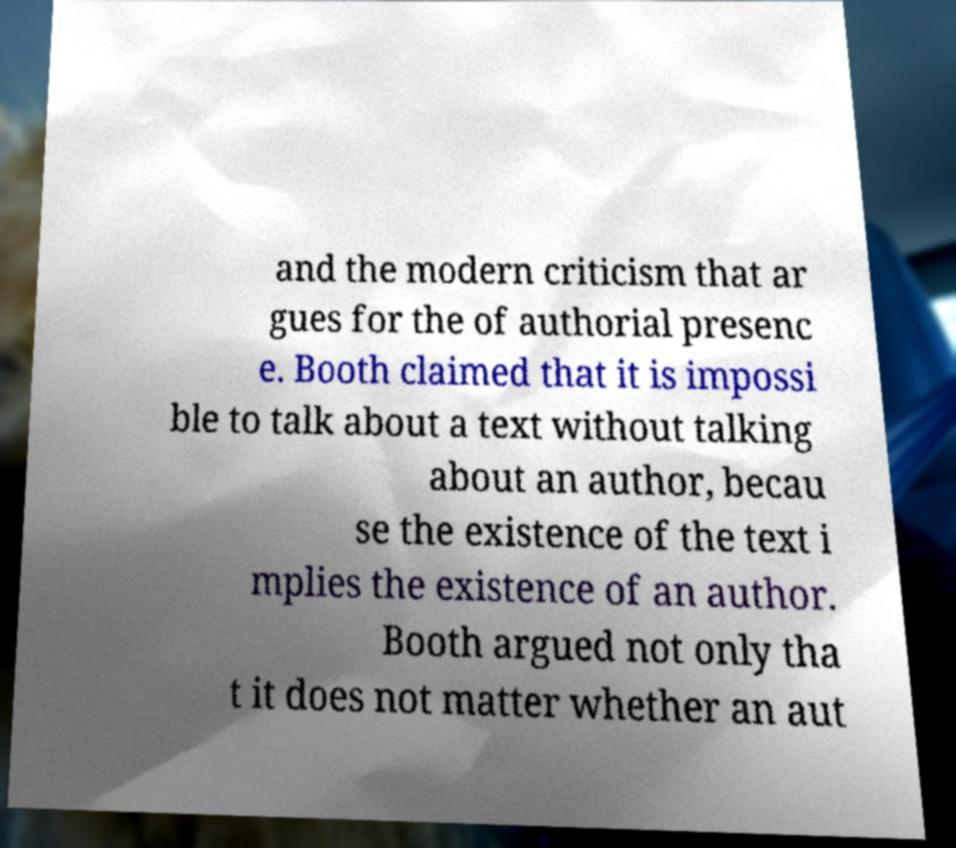What messages or text are displayed in this image? I need them in a readable, typed format. and the modern criticism that ar gues for the of authorial presenc e. Booth claimed that it is impossi ble to talk about a text without talking about an author, becau se the existence of the text i mplies the existence of an author. Booth argued not only tha t it does not matter whether an aut 